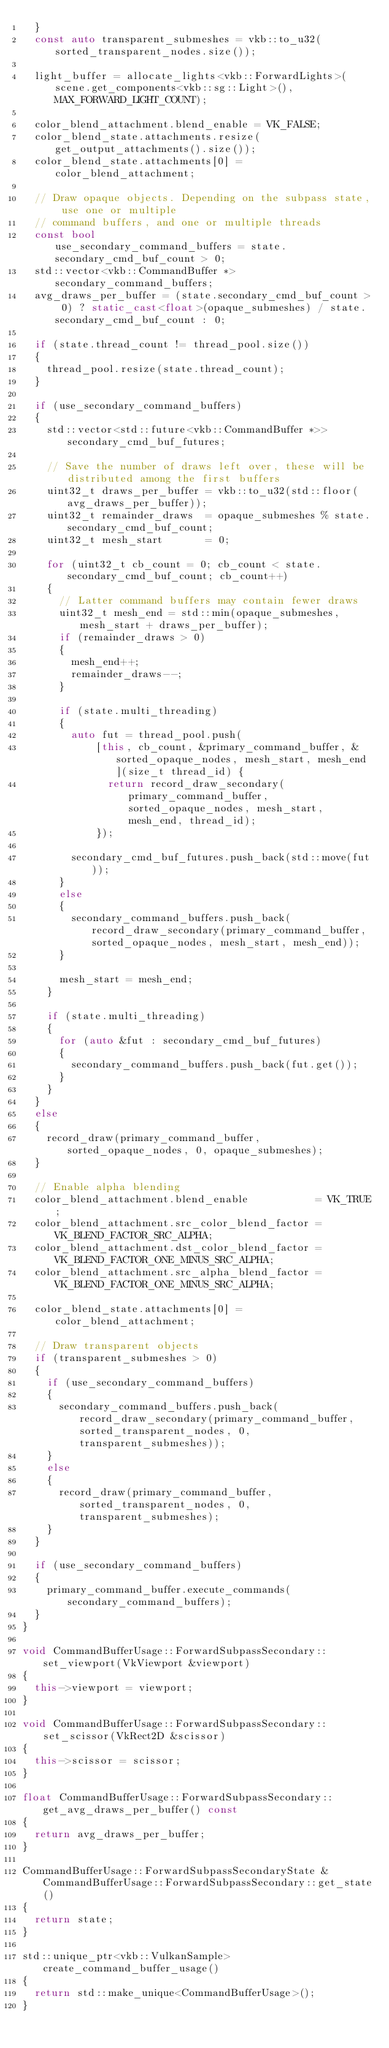Convert code to text. <code><loc_0><loc_0><loc_500><loc_500><_C++_>	}
	const auto transparent_submeshes = vkb::to_u32(sorted_transparent_nodes.size());

	light_buffer = allocate_lights<vkb::ForwardLights>(scene.get_components<vkb::sg::Light>(), MAX_FORWARD_LIGHT_COUNT);

	color_blend_attachment.blend_enable = VK_FALSE;
	color_blend_state.attachments.resize(get_output_attachments().size());
	color_blend_state.attachments[0] = color_blend_attachment;

	// Draw opaque objects. Depending on the subpass state, use one or multiple
	// command buffers, and one or multiple threads
	const bool                        use_secondary_command_buffers = state.secondary_cmd_buf_count > 0;
	std::vector<vkb::CommandBuffer *> secondary_command_buffers;
	avg_draws_per_buffer = (state.secondary_cmd_buf_count > 0) ? static_cast<float>(opaque_submeshes) / state.secondary_cmd_buf_count : 0;

	if (state.thread_count != thread_pool.size())
	{
		thread_pool.resize(state.thread_count);
	}

	if (use_secondary_command_buffers)
	{
		std::vector<std::future<vkb::CommandBuffer *>> secondary_cmd_buf_futures;

		// Save the number of draws left over, these will be distributed among the first buffers
		uint32_t draws_per_buffer = vkb::to_u32(std::floor(avg_draws_per_buffer));
		uint32_t remainder_draws  = opaque_submeshes % state.secondary_cmd_buf_count;
		uint32_t mesh_start       = 0;

		for (uint32_t cb_count = 0; cb_count < state.secondary_cmd_buf_count; cb_count++)
		{
			// Latter command buffers may contain fewer draws
			uint32_t mesh_end = std::min(opaque_submeshes, mesh_start + draws_per_buffer);
			if (remainder_draws > 0)
			{
				mesh_end++;
				remainder_draws--;
			}

			if (state.multi_threading)
			{
				auto fut = thread_pool.push(
				    [this, cb_count, &primary_command_buffer, &sorted_opaque_nodes, mesh_start, mesh_end](size_t thread_id) {
					    return record_draw_secondary(primary_command_buffer, sorted_opaque_nodes, mesh_start, mesh_end, thread_id);
				    });

				secondary_cmd_buf_futures.push_back(std::move(fut));
			}
			else
			{
				secondary_command_buffers.push_back(record_draw_secondary(primary_command_buffer, sorted_opaque_nodes, mesh_start, mesh_end));
			}

			mesh_start = mesh_end;
		}

		if (state.multi_threading)
		{
			for (auto &fut : secondary_cmd_buf_futures)
			{
				secondary_command_buffers.push_back(fut.get());
			}
		}
	}
	else
	{
		record_draw(primary_command_buffer, sorted_opaque_nodes, 0, opaque_submeshes);
	}

	// Enable alpha blending
	color_blend_attachment.blend_enable           = VK_TRUE;
	color_blend_attachment.src_color_blend_factor = VK_BLEND_FACTOR_SRC_ALPHA;
	color_blend_attachment.dst_color_blend_factor = VK_BLEND_FACTOR_ONE_MINUS_SRC_ALPHA;
	color_blend_attachment.src_alpha_blend_factor = VK_BLEND_FACTOR_ONE_MINUS_SRC_ALPHA;

	color_blend_state.attachments[0] = color_blend_attachment;

	// Draw transparent objects
	if (transparent_submeshes > 0)
	{
		if (use_secondary_command_buffers)
		{
			secondary_command_buffers.push_back(record_draw_secondary(primary_command_buffer, sorted_transparent_nodes, 0, transparent_submeshes));
		}
		else
		{
			record_draw(primary_command_buffer, sorted_transparent_nodes, 0, transparent_submeshes);
		}
	}

	if (use_secondary_command_buffers)
	{
		primary_command_buffer.execute_commands(secondary_command_buffers);
	}
}

void CommandBufferUsage::ForwardSubpassSecondary::set_viewport(VkViewport &viewport)
{
	this->viewport = viewport;
}

void CommandBufferUsage::ForwardSubpassSecondary::set_scissor(VkRect2D &scissor)
{
	this->scissor = scissor;
}

float CommandBufferUsage::ForwardSubpassSecondary::get_avg_draws_per_buffer() const
{
	return avg_draws_per_buffer;
}

CommandBufferUsage::ForwardSubpassSecondaryState &CommandBufferUsage::ForwardSubpassSecondary::get_state()
{
	return state;
}

std::unique_ptr<vkb::VulkanSample> create_command_buffer_usage()
{
	return std::make_unique<CommandBufferUsage>();
}
</code> 